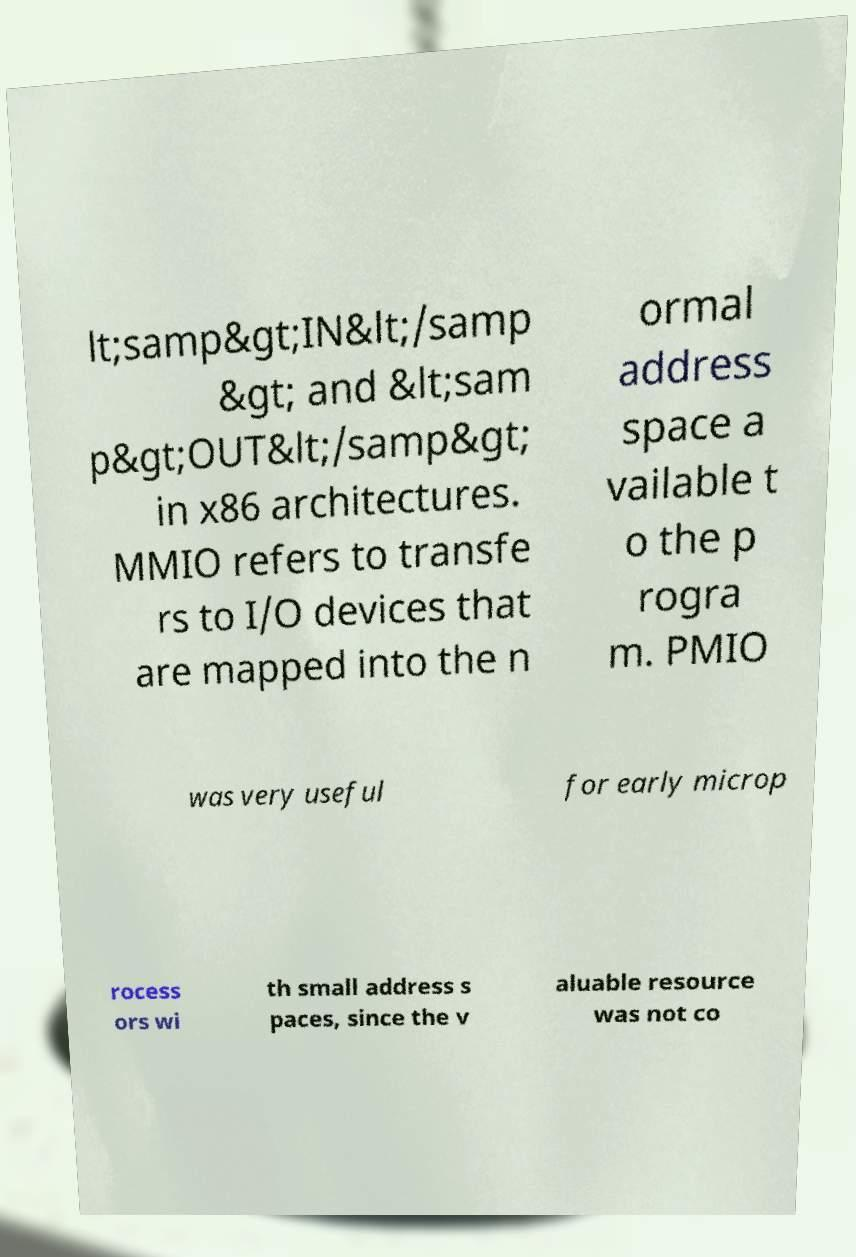For documentation purposes, I need the text within this image transcribed. Could you provide that? lt;samp&gt;IN&lt;/samp &gt; and &lt;sam p&gt;OUT&lt;/samp&gt; in x86 architectures. MMIO refers to transfe rs to I/O devices that are mapped into the n ormal address space a vailable t o the p rogra m. PMIO was very useful for early microp rocess ors wi th small address s paces, since the v aluable resource was not co 